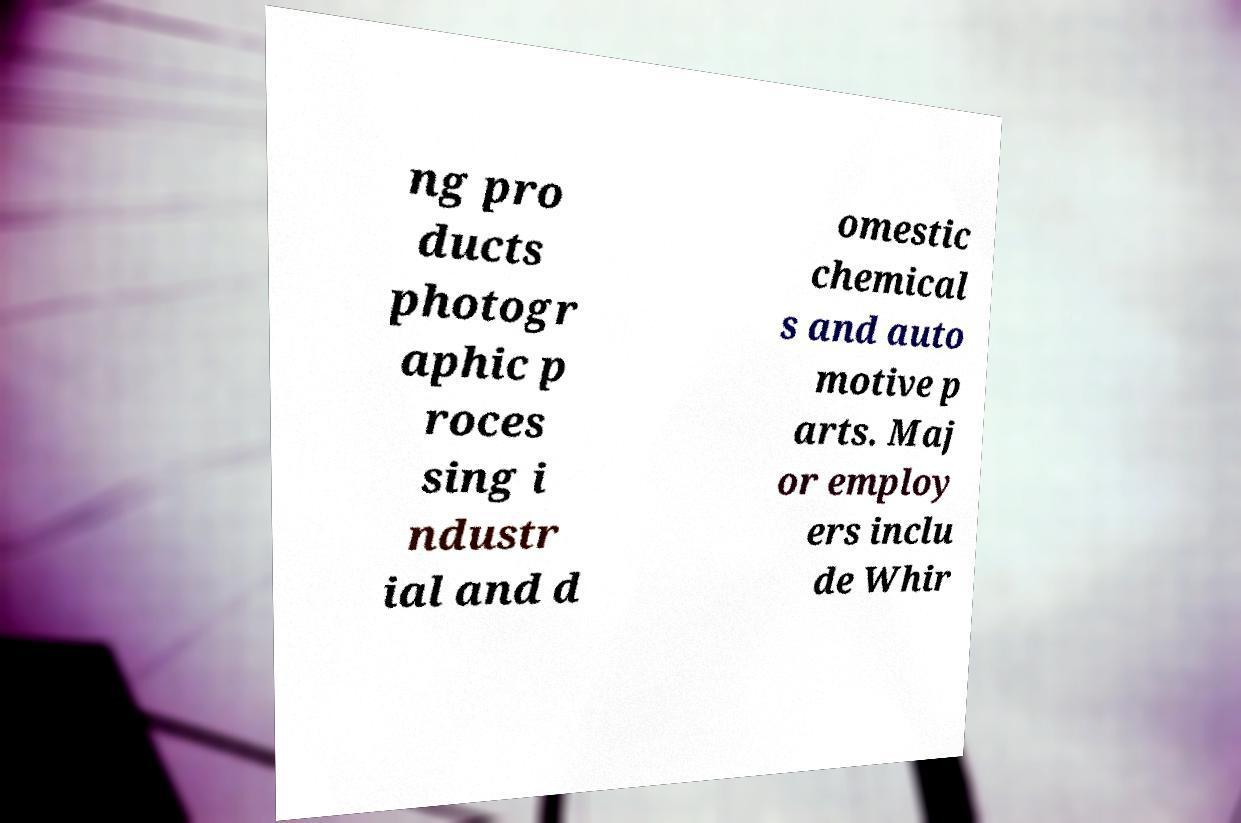There's text embedded in this image that I need extracted. Can you transcribe it verbatim? ng pro ducts photogr aphic p roces sing i ndustr ial and d omestic chemical s and auto motive p arts. Maj or employ ers inclu de Whir 